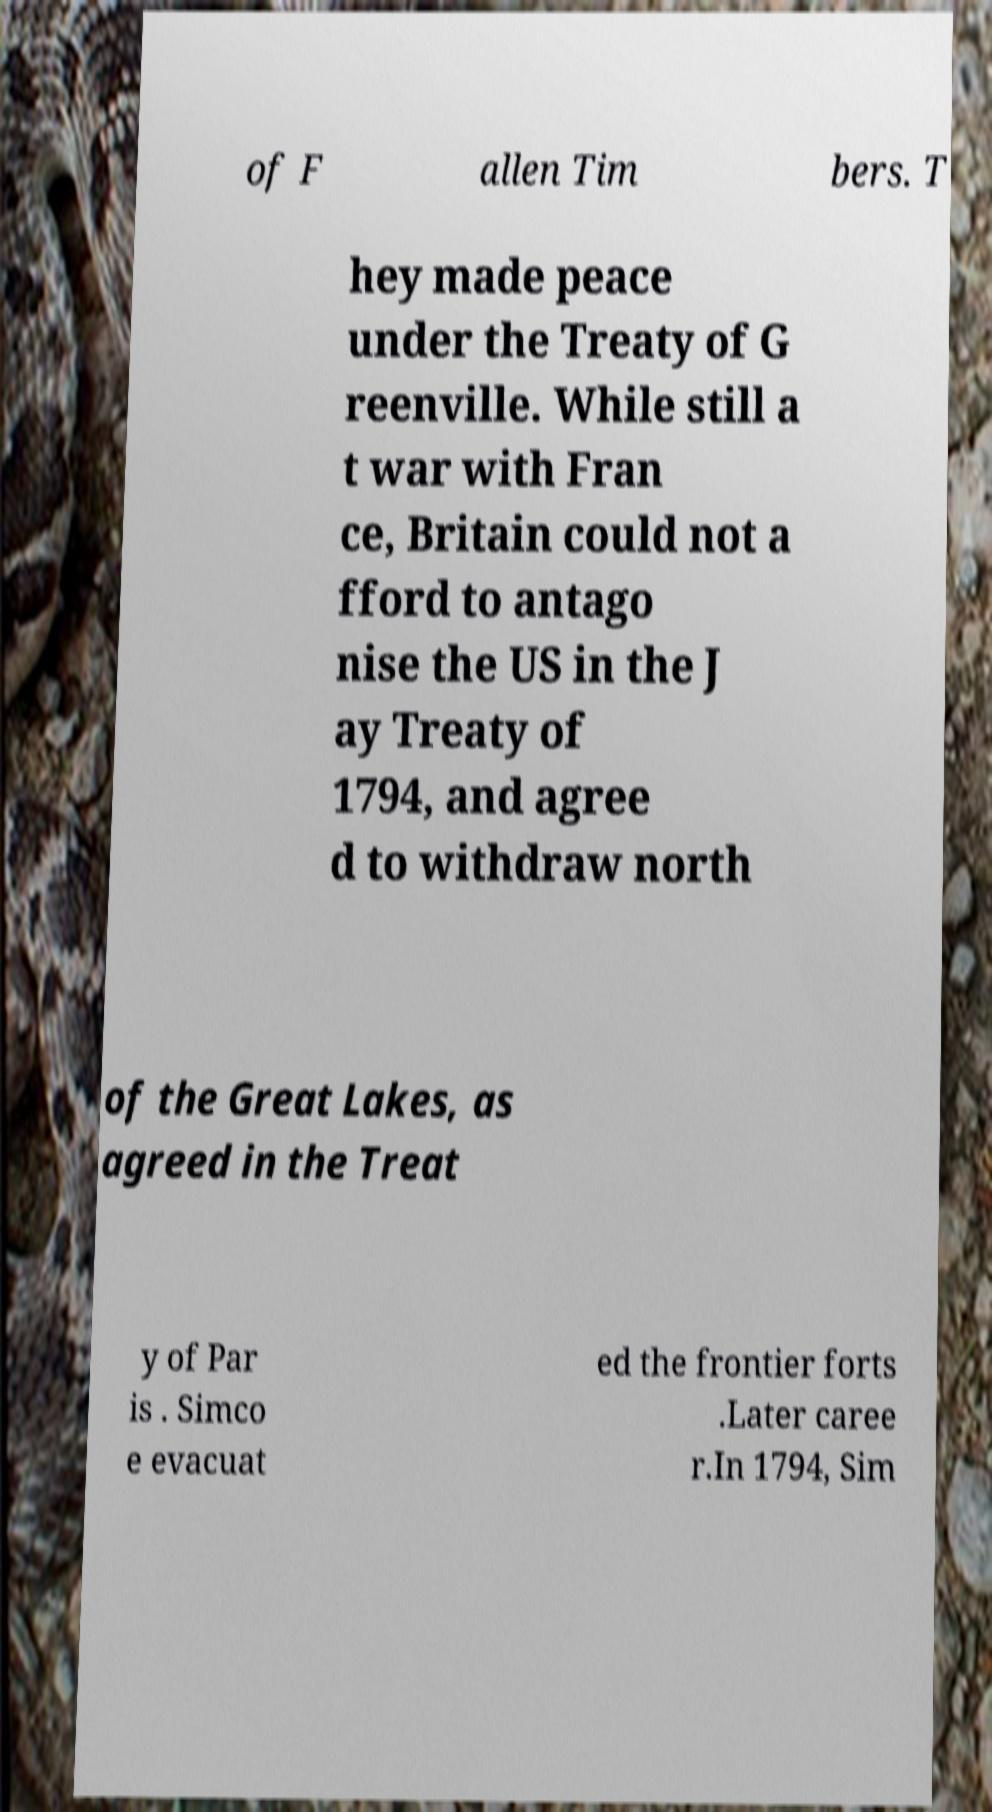I need the written content from this picture converted into text. Can you do that? of F allen Tim bers. T hey made peace under the Treaty of G reenville. While still a t war with Fran ce, Britain could not a fford to antago nise the US in the J ay Treaty of 1794, and agree d to withdraw north of the Great Lakes, as agreed in the Treat y of Par is . Simco e evacuat ed the frontier forts .Later caree r.In 1794, Sim 